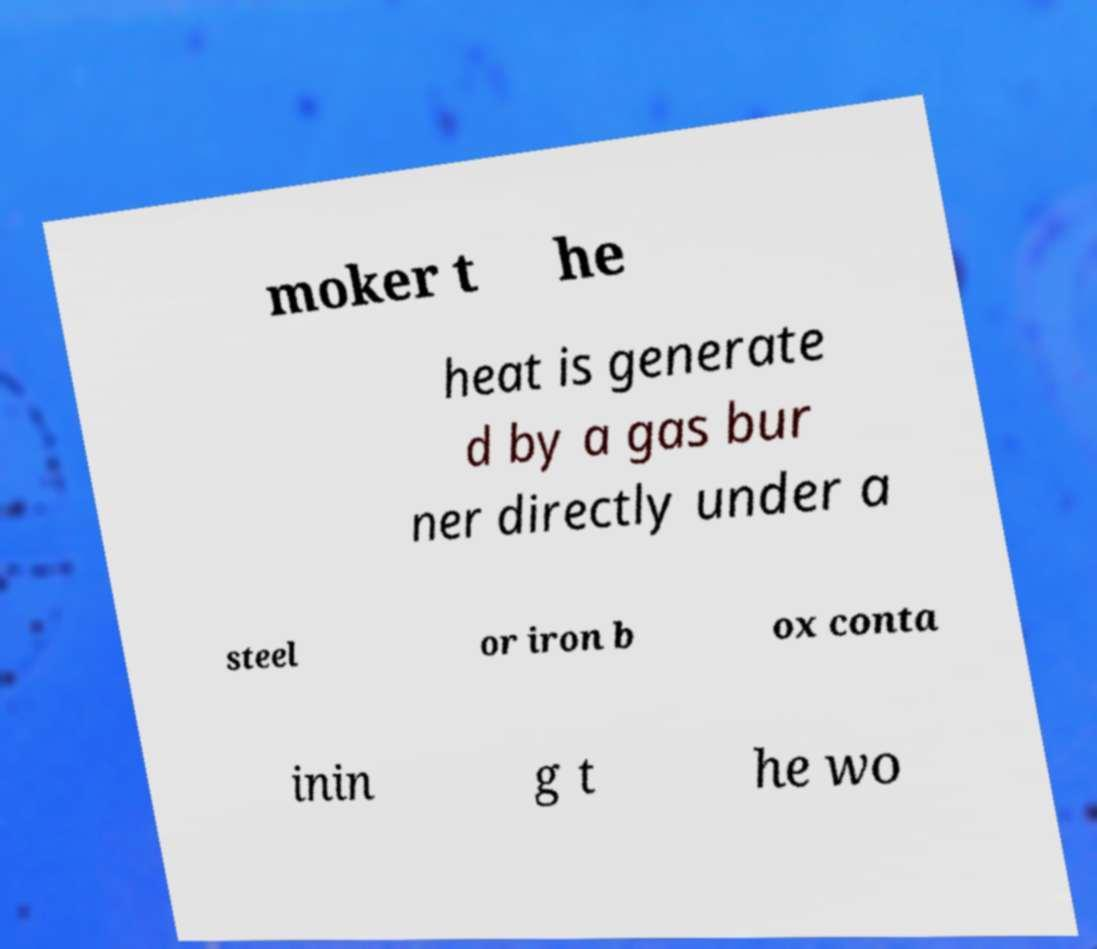Can you read and provide the text displayed in the image?This photo seems to have some interesting text. Can you extract and type it out for me? moker t he heat is generate d by a gas bur ner directly under a steel or iron b ox conta inin g t he wo 